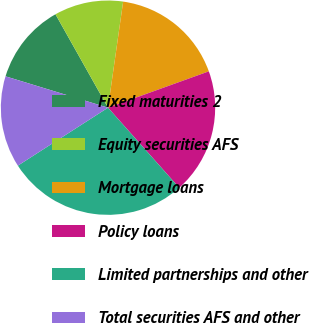Convert chart. <chart><loc_0><loc_0><loc_500><loc_500><pie_chart><fcel>Fixed maturities 2<fcel>Equity securities AFS<fcel>Mortgage loans<fcel>Policy loans<fcel>Limited partnerships and other<fcel>Total securities AFS and other<nl><fcel>12.12%<fcel>10.41%<fcel>17.24%<fcel>18.94%<fcel>27.47%<fcel>13.82%<nl></chart> 